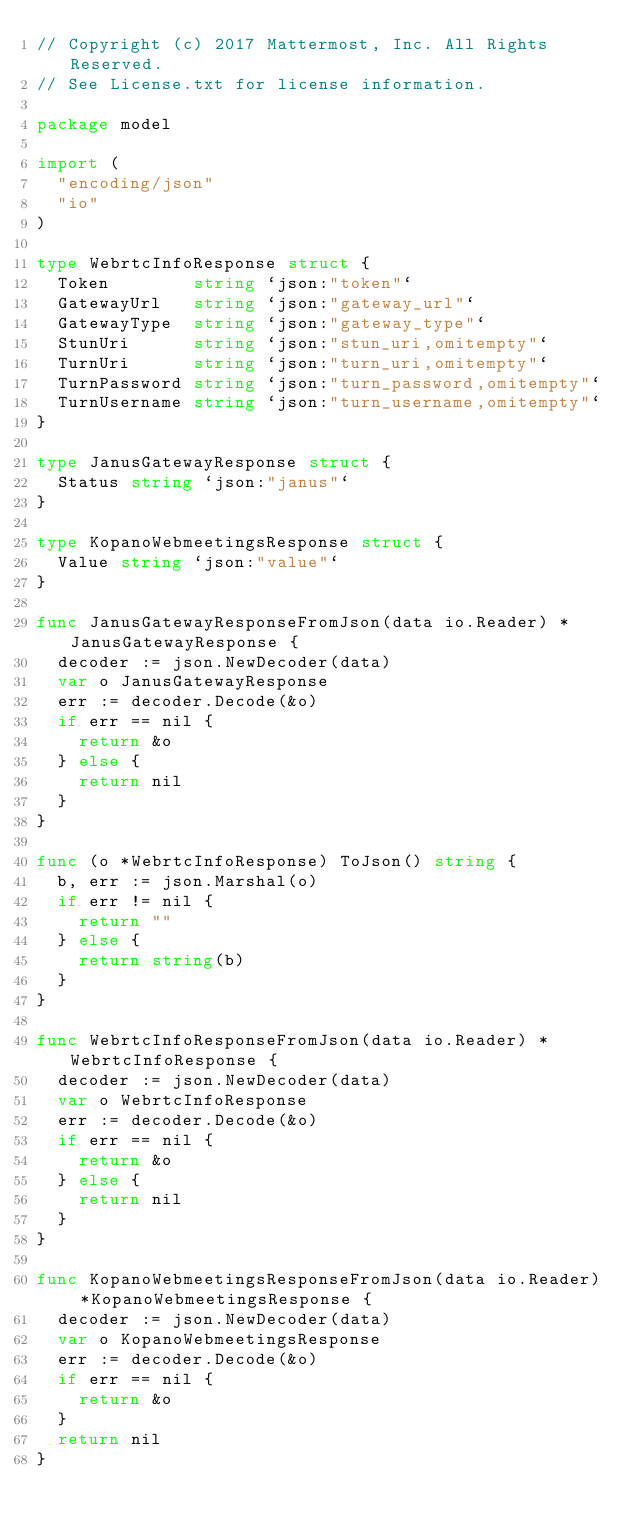<code> <loc_0><loc_0><loc_500><loc_500><_Go_>// Copyright (c) 2017 Mattermost, Inc. All Rights Reserved.
// See License.txt for license information.

package model

import (
	"encoding/json"
	"io"
)

type WebrtcInfoResponse struct {
	Token        string `json:"token"`
	GatewayUrl   string `json:"gateway_url"`
	GatewayType  string `json:"gateway_type"`
	StunUri      string `json:"stun_uri,omitempty"`
	TurnUri      string `json:"turn_uri,omitempty"`
	TurnPassword string `json:"turn_password,omitempty"`
	TurnUsername string `json:"turn_username,omitempty"`
}

type JanusGatewayResponse struct {
	Status string `json:"janus"`
}

type KopanoWebmeetingsResponse struct {
	Value string `json:"value"`
}

func JanusGatewayResponseFromJson(data io.Reader) *JanusGatewayResponse {
	decoder := json.NewDecoder(data)
	var o JanusGatewayResponse
	err := decoder.Decode(&o)
	if err == nil {
		return &o
	} else {
		return nil
	}
}

func (o *WebrtcInfoResponse) ToJson() string {
	b, err := json.Marshal(o)
	if err != nil {
		return ""
	} else {
		return string(b)
	}
}

func WebrtcInfoResponseFromJson(data io.Reader) *WebrtcInfoResponse {
	decoder := json.NewDecoder(data)
	var o WebrtcInfoResponse
	err := decoder.Decode(&o)
	if err == nil {
		return &o
	} else {
		return nil
	}
}

func KopanoWebmeetingsResponseFromJson(data io.Reader) *KopanoWebmeetingsResponse {
	decoder := json.NewDecoder(data)
	var o KopanoWebmeetingsResponse
	err := decoder.Decode(&o)
	if err == nil {
		return &o
	}
	return nil
}
</code> 